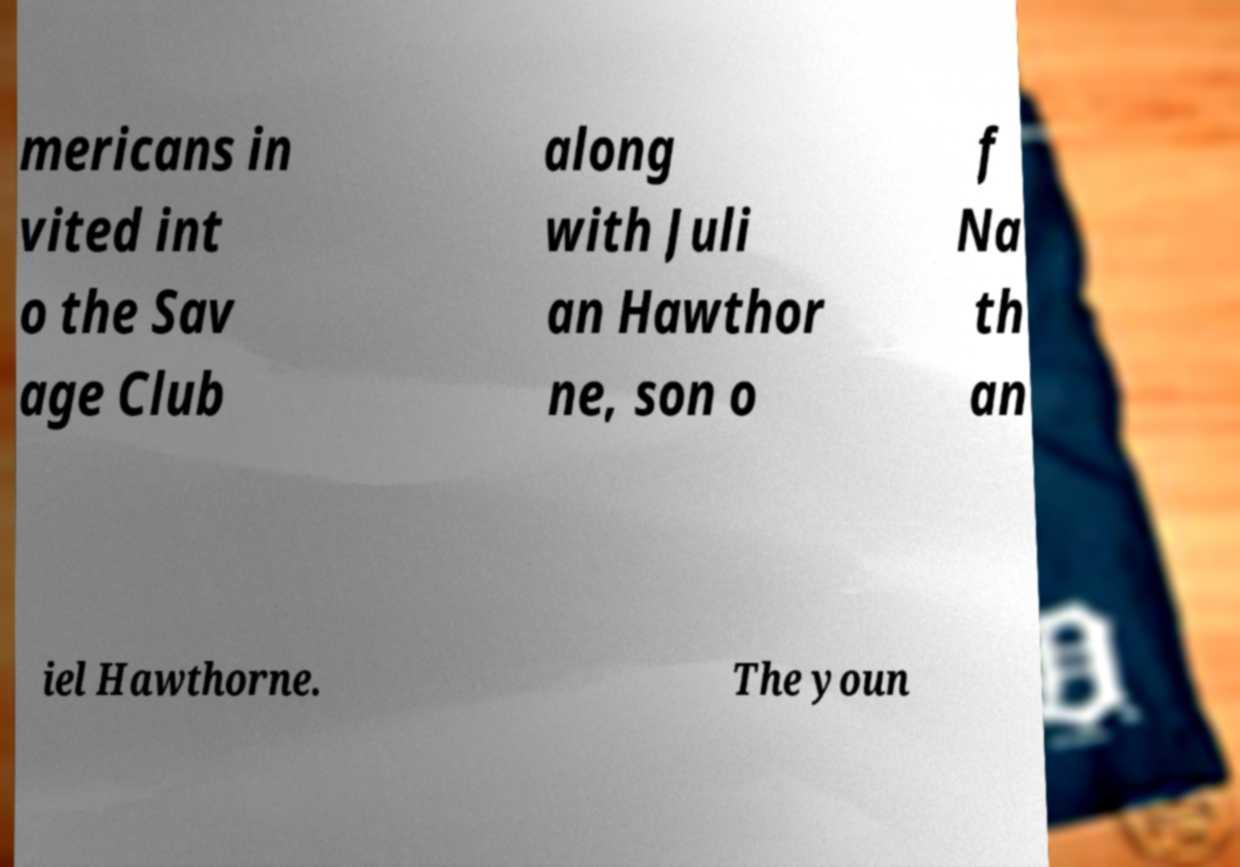Could you assist in decoding the text presented in this image and type it out clearly? mericans in vited int o the Sav age Club along with Juli an Hawthor ne, son o f Na th an iel Hawthorne. The youn 